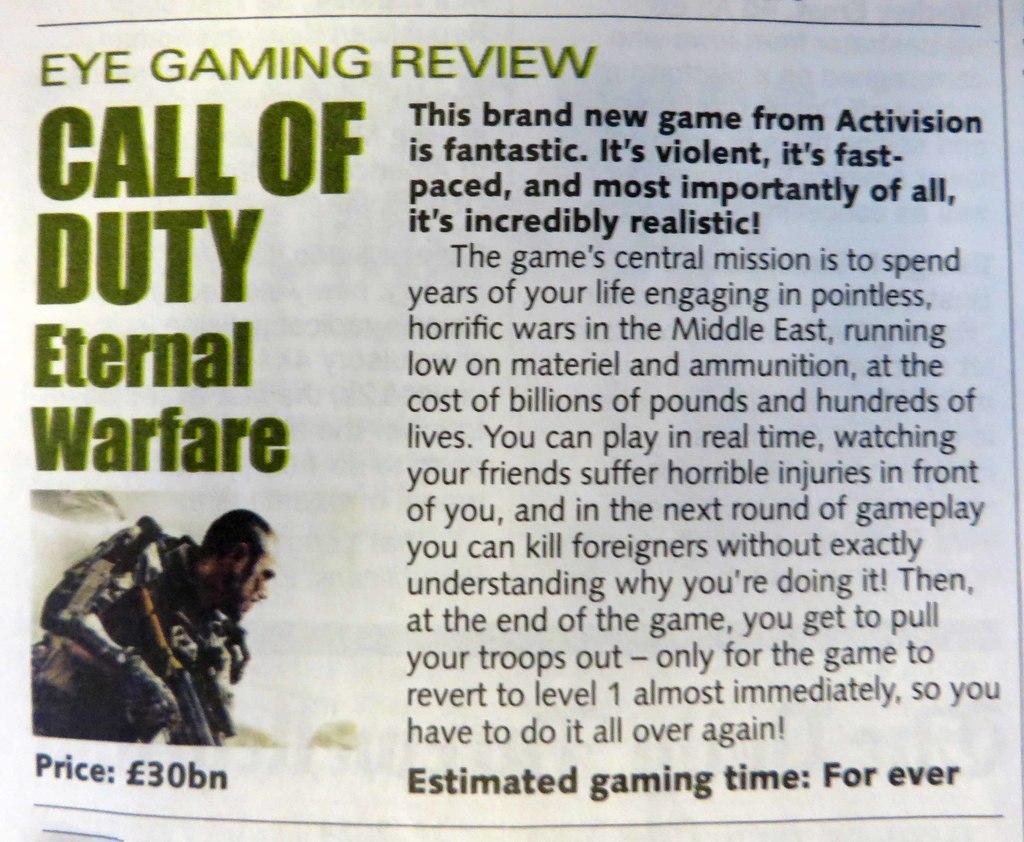<image>
Summarize the visual content of the image. A very positive review for Call Of Duty: External Warfare. 